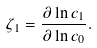Convert formula to latex. <formula><loc_0><loc_0><loc_500><loc_500>\zeta _ { 1 } = \frac { \partial \ln c _ { 1 } } { \partial \ln c _ { 0 } } .</formula> 